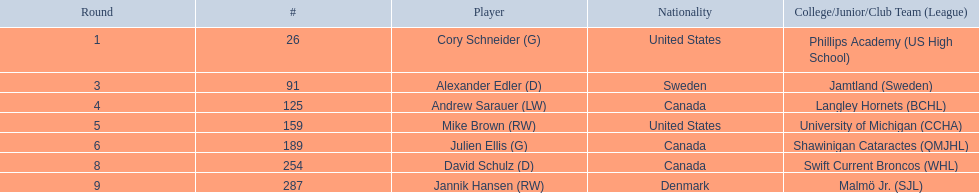What are the names of the colleges and jr leagues the players attended? Phillips Academy (US High School), Jamtland (Sweden), Langley Hornets (BCHL), University of Michigan (CCHA), Shawinigan Cataractes (QMJHL), Swift Current Broncos (WHL), Malmö Jr. (SJL). Which player played for the langley hornets? Andrew Sarauer (LW). 